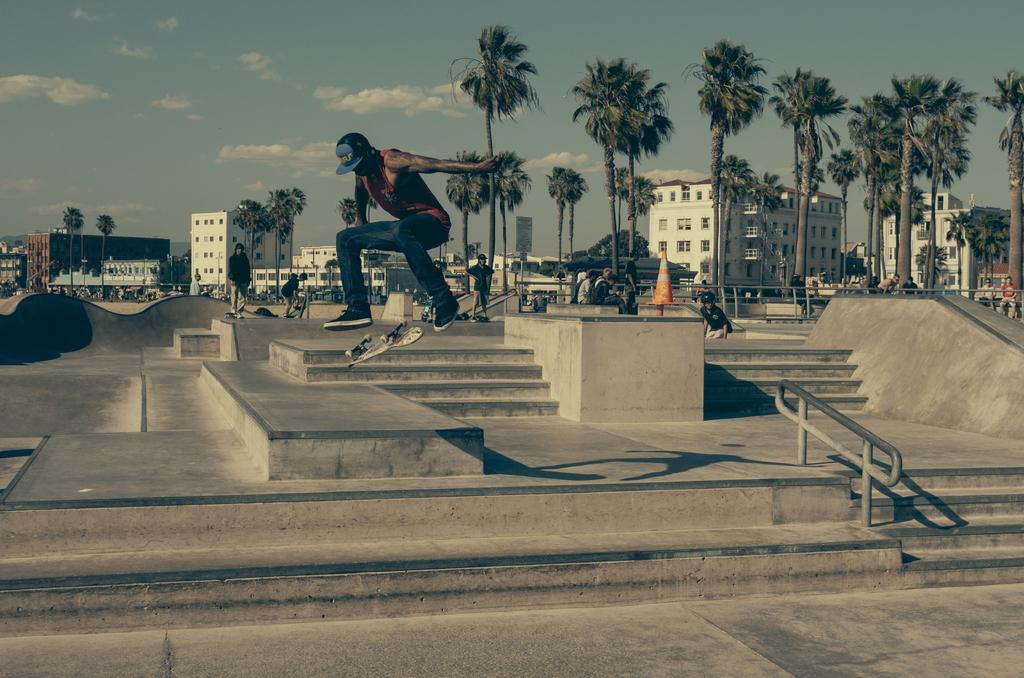What is the person in the image doing? The person is on a skateboard in the air. What can be seen in the background of the image? There are people, steps, buildings, a traffic cone, and trees in the background. What is the condition of the sky in the image? There are clouds visible in the image. How much money is the ant carrying in the image? There is no ant present in the image, and therefore no money can be observed. 